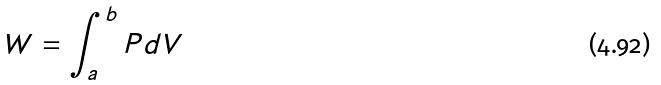Convert formula to latex. <formula><loc_0><loc_0><loc_500><loc_500>W = \int _ { a } ^ { b } P d V</formula> 